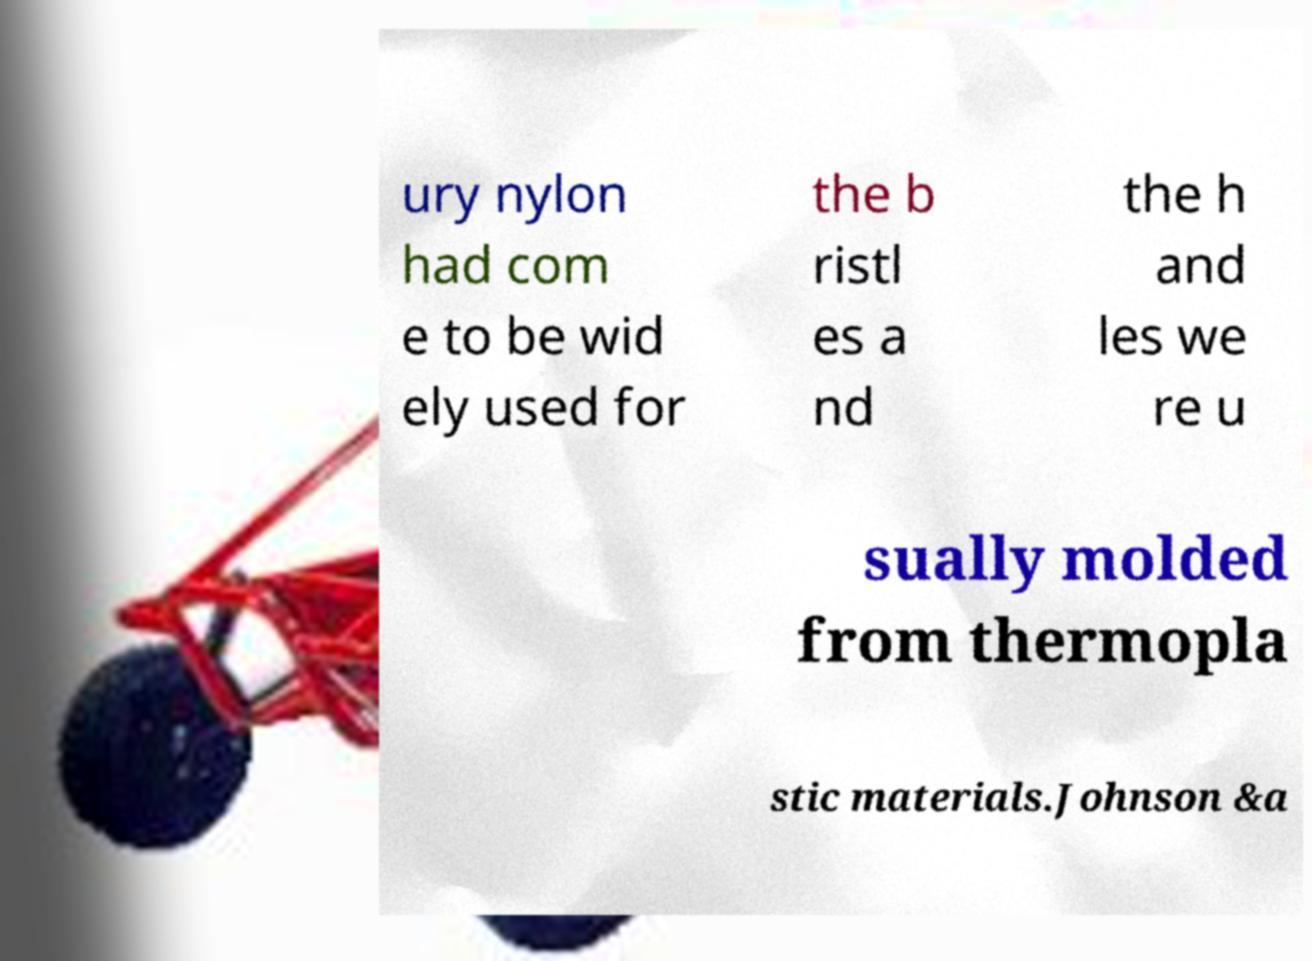Can you accurately transcribe the text from the provided image for me? ury nylon had com e to be wid ely used for the b ristl es a nd the h and les we re u sually molded from thermopla stic materials.Johnson &a 